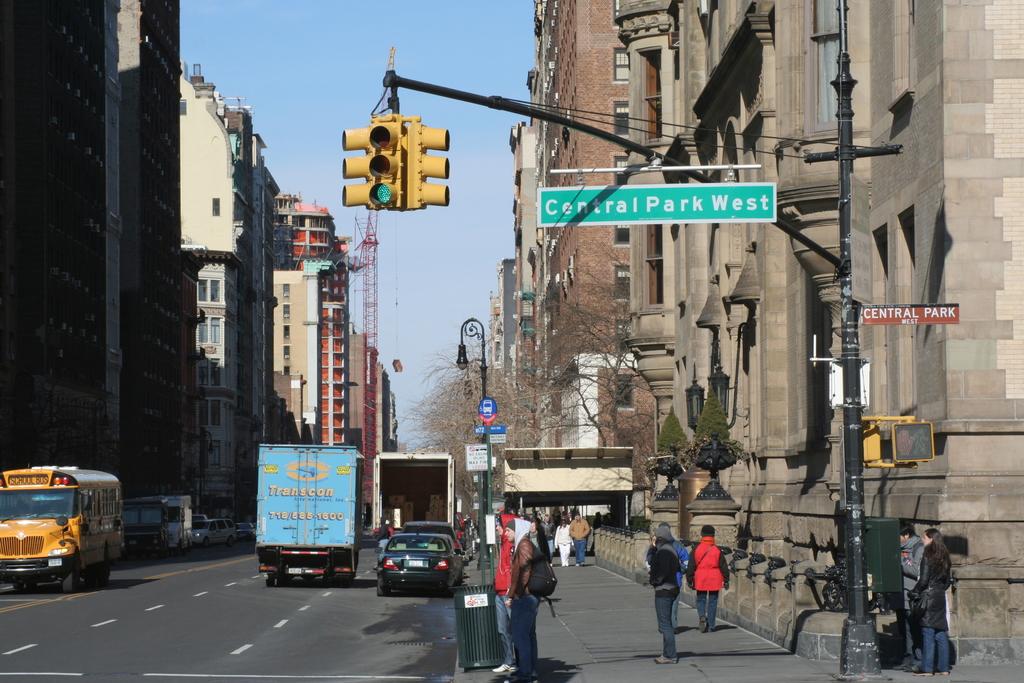What road are these people on?
Provide a short and direct response. Central park west. 